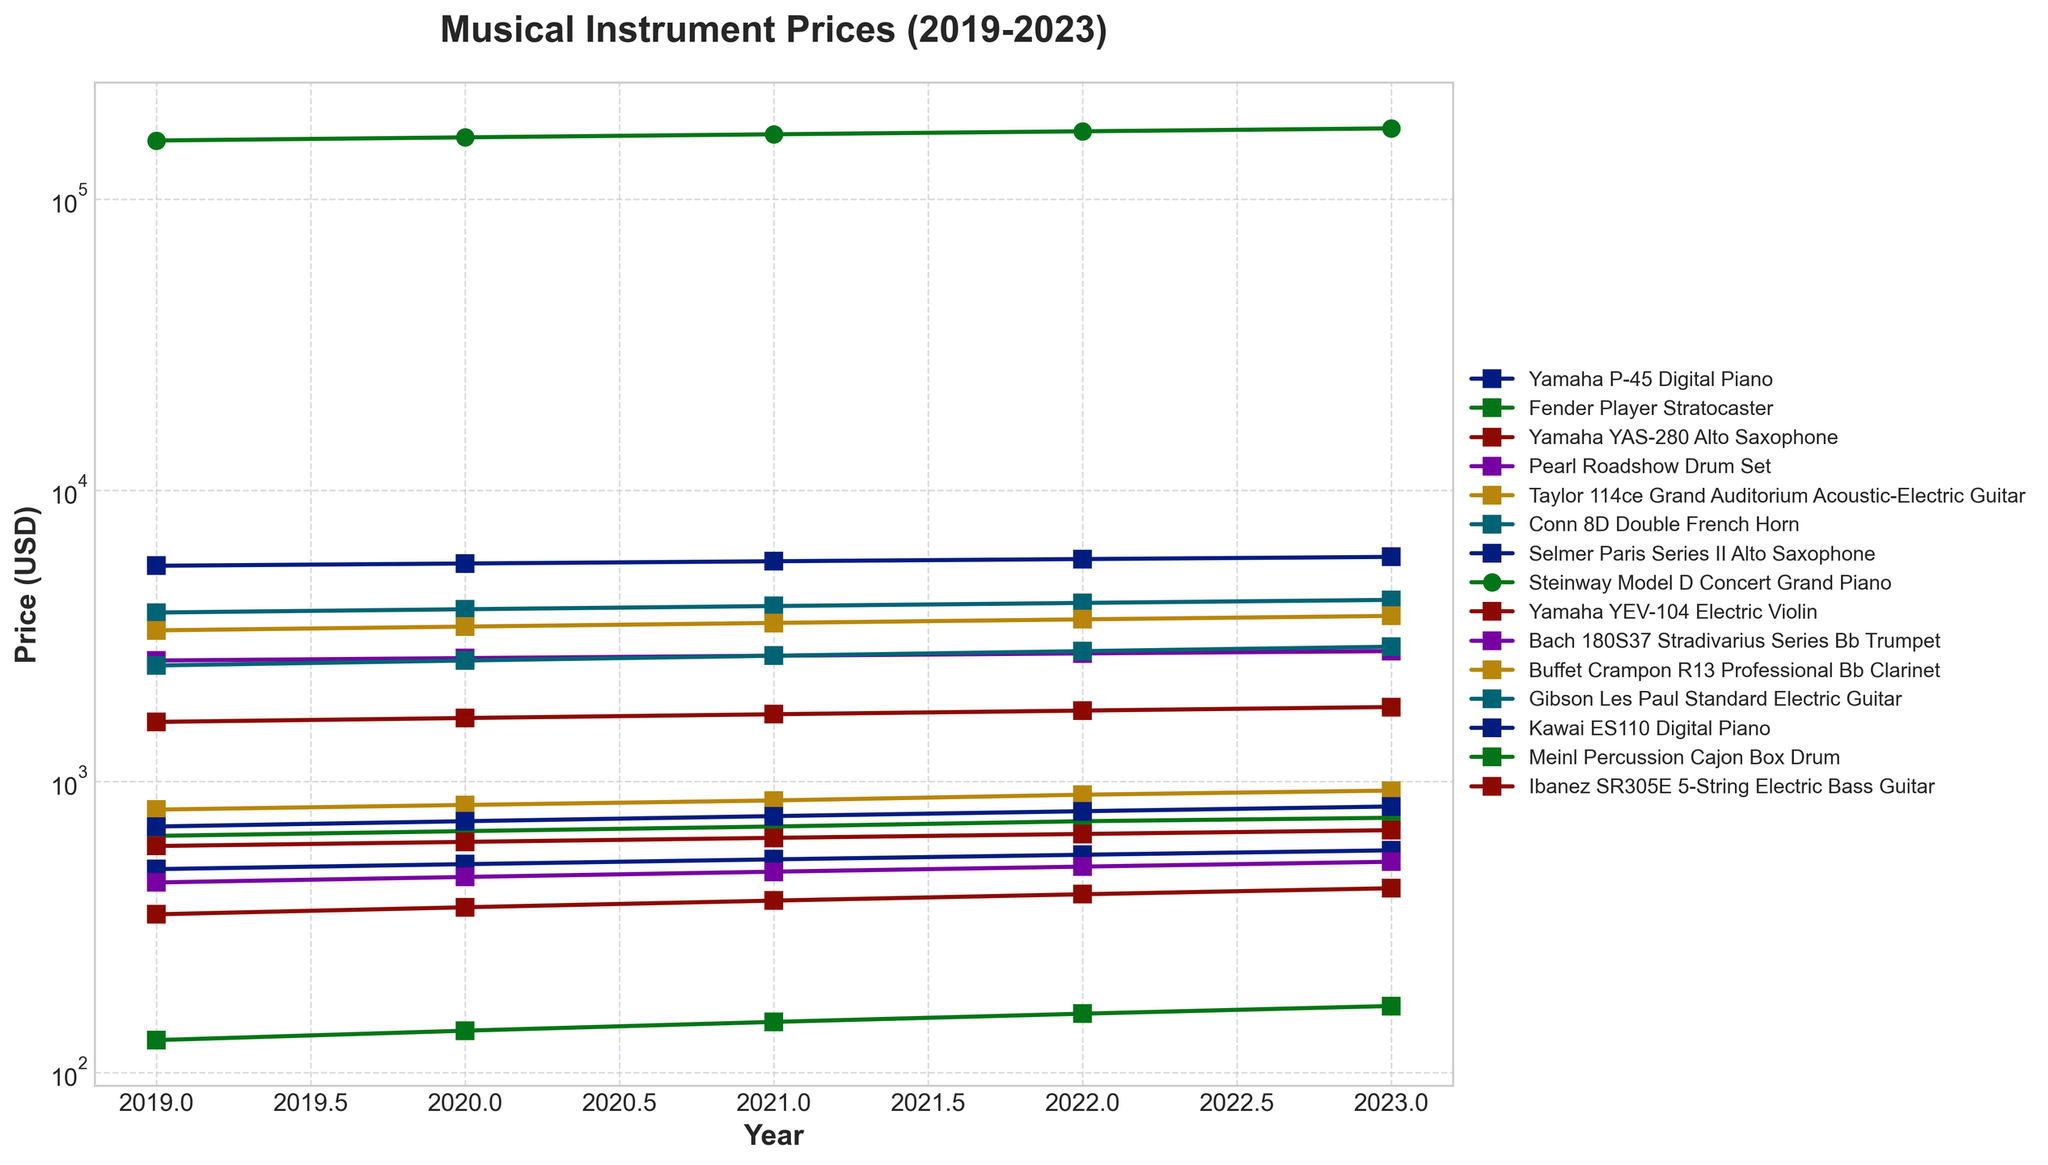What was the price increase trend for the Yamaha P-45 Digital Piano over the 5 years? Look at the plotted line for the Yamaha P-45 Digital Piano. Note the prices for each year from 2019 to 2023. The prices increased from $499 in 2019 to $579 in 2023.
Answer: Increased steadily Which instrument's price had the highest growth from 2019 to 2023? Review the prices for each instrument in 2019 and compare them to their prices in 2023. Calculate the difference for each instrument. The Steinway Model D Concert Grand Piano increased by $16,000 over this period.
Answer: Steinway Model D Concert Grand Piano Between the Fender Player Stratocaster and the Gibson Les Paul Standard Electric Guitar, which one experienced a higher price increase percentage? Calculate the price increase percentage for both instruments from 2019 to 2023. For the Fender Player Stratocaster: [(749-649)/649]*100 ≈ 15.4%. For the Gibson Les Paul: [(2899-2499)/2499]*100 ≈ 16.0%.
Answer: Gibson Les Paul Standard Electric Guitar What was the trend for the Yamaha YAS-280 Alto Saxophone's price from 2019 to 2023? Look at the plotted line for the Yamaha YAS-280 Alto Saxophone and observe the prices from 2019 to 2023. Note that the instrument’s price increased from $1599 in 2019 to $1799 in 2023 in a steady manner.
Answer: Steadily increased How do the price changes of the Pearl Roadshow Drum Set compare to those of the Meinl Percussion Cajon Box Drum from 2019 to 2023? Examine the plotted lines for both instruments. The Pearl Roadshow Drum Set increased from $449 to $529, and the Meinl Percussion Cajon Box Drum increased from $129 to $169. Calculate the absolute difference: ($529-$449)=$80 and ($169-$129)=$40.
Answer: Pearl Roadshow Drum Set increased more Which instrument shows the most consistent yearly price increase over the period? Check the plotted lines and find the instrument with equal yearly price increases. The Conn 8D Double French Horn increased by $100 each year from 2019 to 2023.
Answer: Conn 8D Double French Horn What is the average price of the Taylor 114ce Grand Auditorium Acoustic-Electric Guitar over the five years? Add the prices of the Taylor 114ce Grand Auditorium Acoustic-Electric Guitar from 2019 to 2023: ($799+$829+$859+$899+$929)=$4315. Then divide by 5. $\frac{4315}{5}$
Answer: $863 How do the starting (2019) and ending (2023) prices of digital pianos (Yamaha P-45 and Kawai ES110) compare? Note the prices for Yamaha P-45 and Kawai ES110 in 2019 and 2023: Yamaha P-45 ($499 to $579) and Kawai ES110 ($699 to $819). Compare both the starting and ending prices.
Answer: Kawai ES110 is higher Identify the instrument with the steepest visual price increase on the chart? Look for the instrument with the sharpest upward line. The Steinway Model D Concert Grand Piano has the steepest slope, indicating the highest price increase visually.
Answer: Steinway Model D Concert Grand Piano Which instruments have a log-scale representation on the chart and why? Identify the instruments plotted on a semi-logarithmic scale, typically those with the highest prices. Instruments like the Steinway Model D Concert Grand Piano and Selmer Paris Series II Alto Saxophone are shown using log scale to accommodate their high values.
Answer: Selmer Paris Series II Alto Saxophone and Steinway Model D Concert Grand Piano 